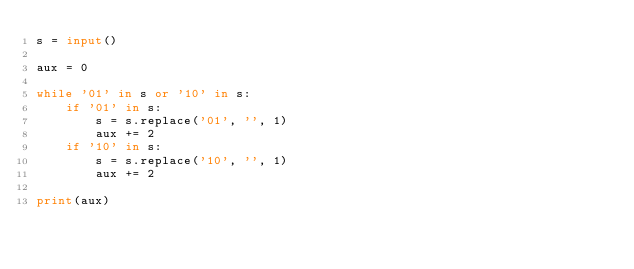<code> <loc_0><loc_0><loc_500><loc_500><_Python_>s = input()

aux = 0

while '01' in s or '10' in s:
    if '01' in s:
        s = s.replace('01', '', 1)
        aux += 2
    if '10' in s:
        s = s.replace('10', '', 1)
        aux += 2

print(aux)
</code> 